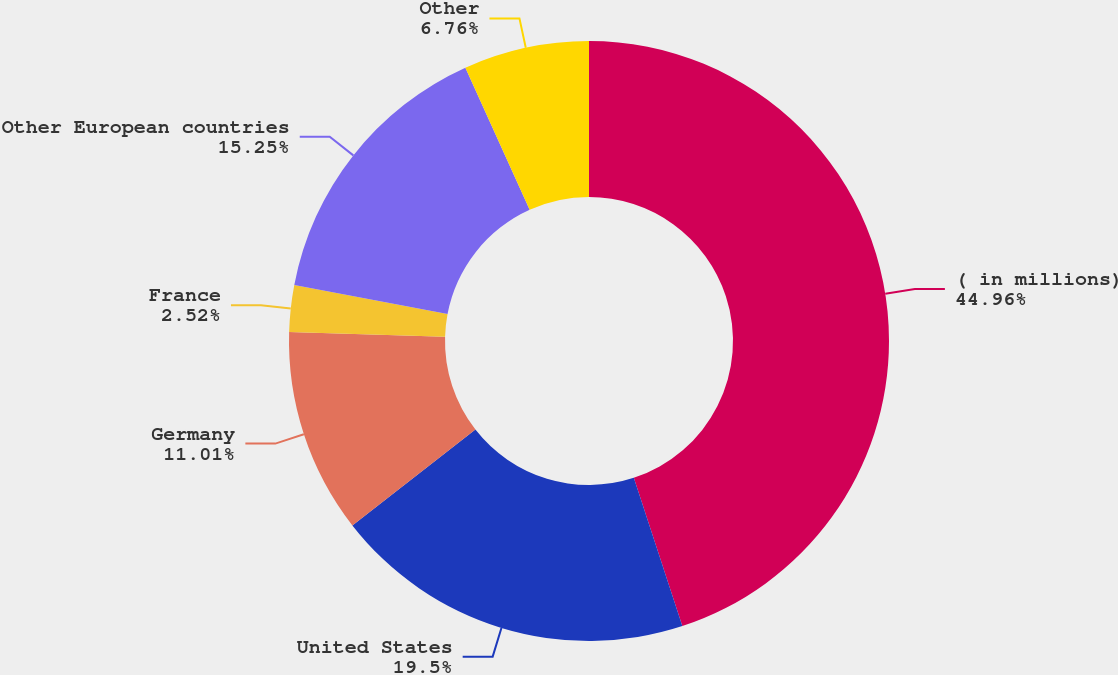<chart> <loc_0><loc_0><loc_500><loc_500><pie_chart><fcel>( in millions)<fcel>United States<fcel>Germany<fcel>France<fcel>Other European countries<fcel>Other<nl><fcel>44.97%<fcel>19.5%<fcel>11.01%<fcel>2.52%<fcel>15.25%<fcel>6.76%<nl></chart> 